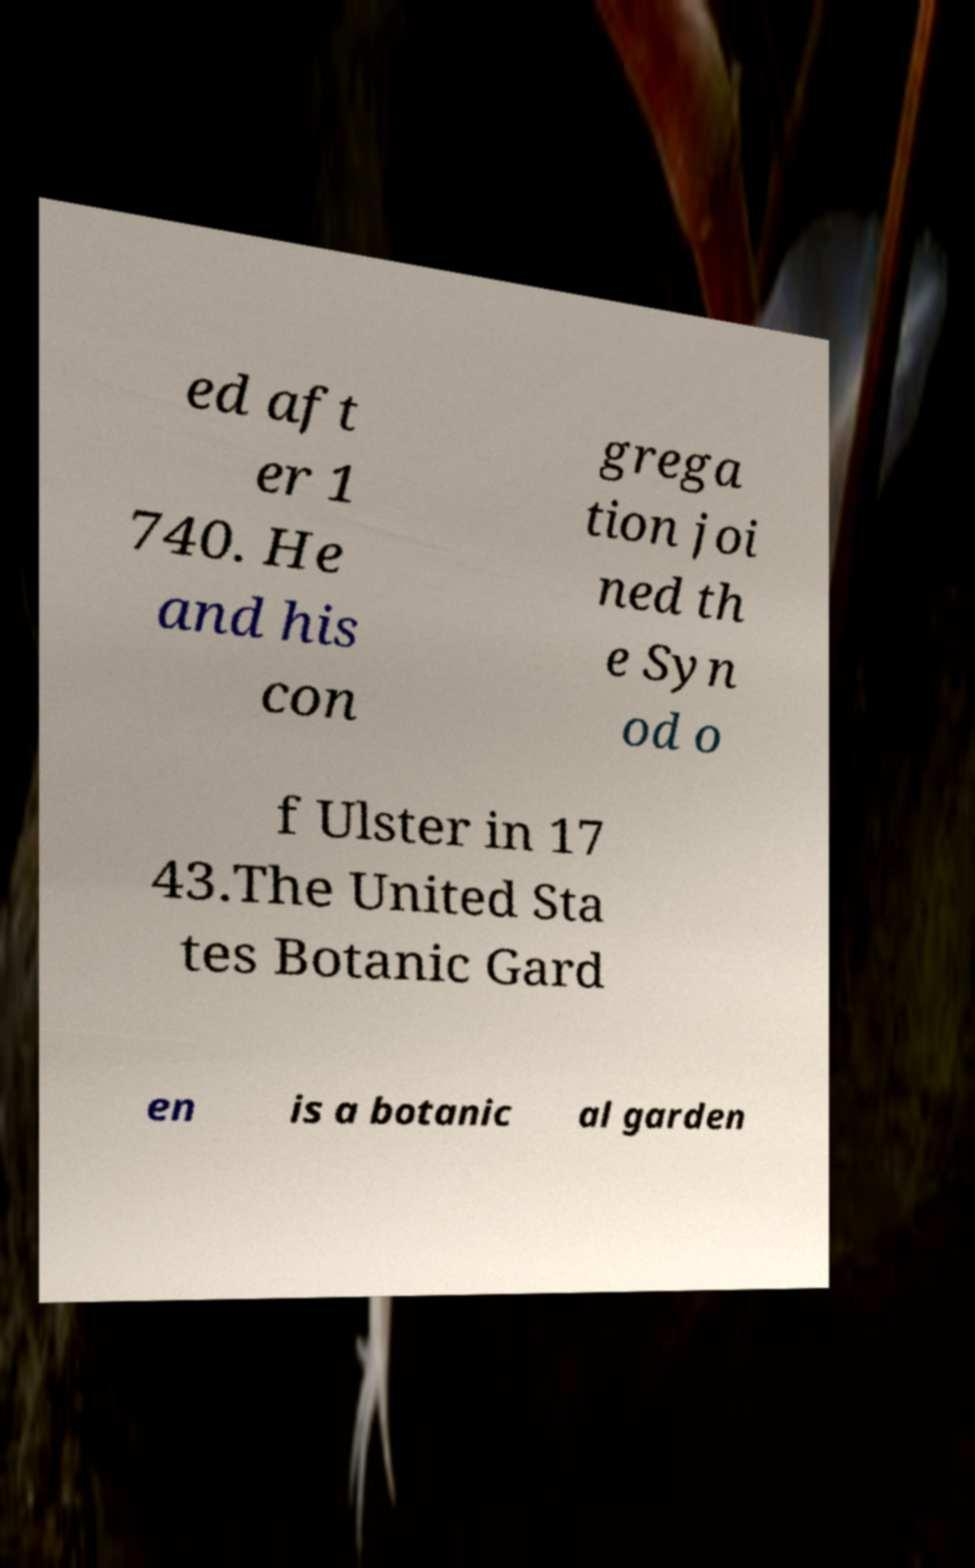Can you accurately transcribe the text from the provided image for me? ed aft er 1 740. He and his con grega tion joi ned th e Syn od o f Ulster in 17 43.The United Sta tes Botanic Gard en is a botanic al garden 